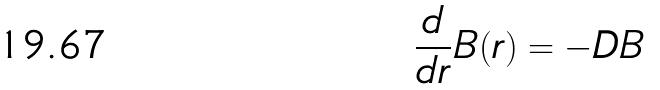Convert formula to latex. <formula><loc_0><loc_0><loc_500><loc_500>\frac { d } { d r } B ( r ) = - D B</formula> 